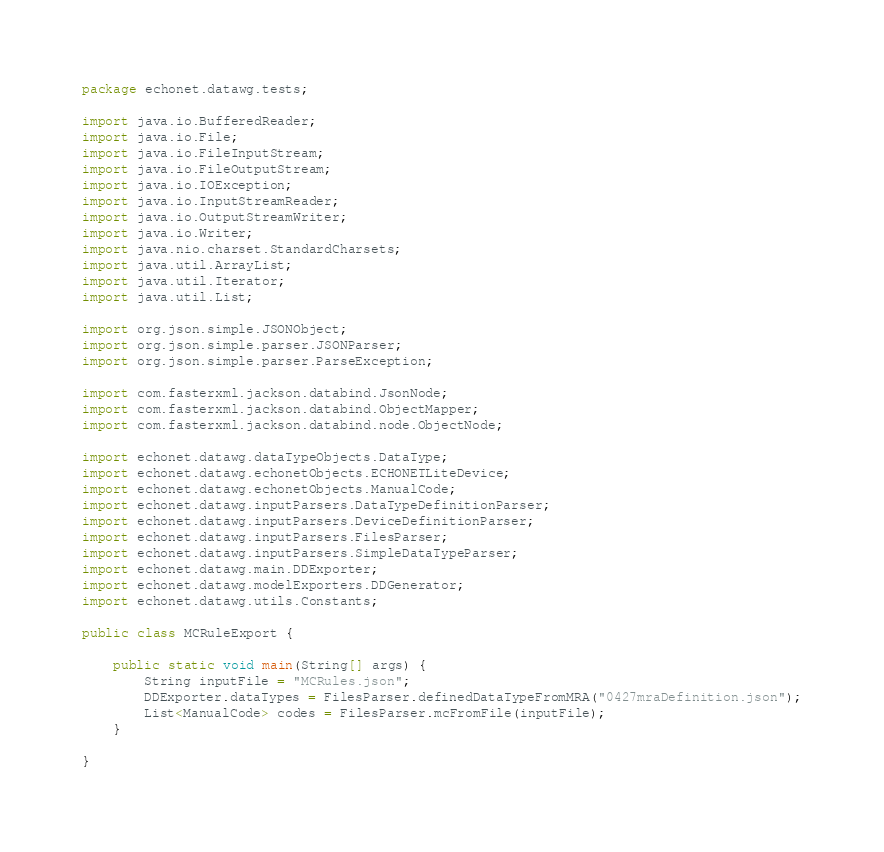Convert code to text. <code><loc_0><loc_0><loc_500><loc_500><_Java_>package echonet.datawg.tests;

import java.io.BufferedReader;
import java.io.File;
import java.io.FileInputStream;
import java.io.FileOutputStream;
import java.io.IOException;
import java.io.InputStreamReader;
import java.io.OutputStreamWriter;
import java.io.Writer;
import java.nio.charset.StandardCharsets;
import java.util.ArrayList;
import java.util.Iterator;
import java.util.List;

import org.json.simple.JSONObject;
import org.json.simple.parser.JSONParser;
import org.json.simple.parser.ParseException;

import com.fasterxml.jackson.databind.JsonNode;
import com.fasterxml.jackson.databind.ObjectMapper;
import com.fasterxml.jackson.databind.node.ObjectNode;

import echonet.datawg.dataTypeObjects.DataType;
import echonet.datawg.echonetObjects.ECHONETLiteDevice;
import echonet.datawg.echonetObjects.ManualCode;
import echonet.datawg.inputParsers.DataTypeDefinitionParser;
import echonet.datawg.inputParsers.DeviceDefinitionParser;
import echonet.datawg.inputParsers.FilesParser;
import echonet.datawg.inputParsers.SimpleDataTypeParser;
import echonet.datawg.main.DDExporter;
import echonet.datawg.modelExporters.DDGenerator;
import echonet.datawg.utils.Constants;

public class MCRuleExport {

	public static void main(String[] args) {
		String inputFile = "MCRules.json";
		DDExporter.dataTypes = FilesParser.definedDataTypeFromMRA("0427mraDefinition.json");
		List<ManualCode> codes = FilesParser.mcFromFile(inputFile);
	}

}
</code> 